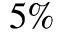<formula> <loc_0><loc_0><loc_500><loc_500>5 \%</formula> 